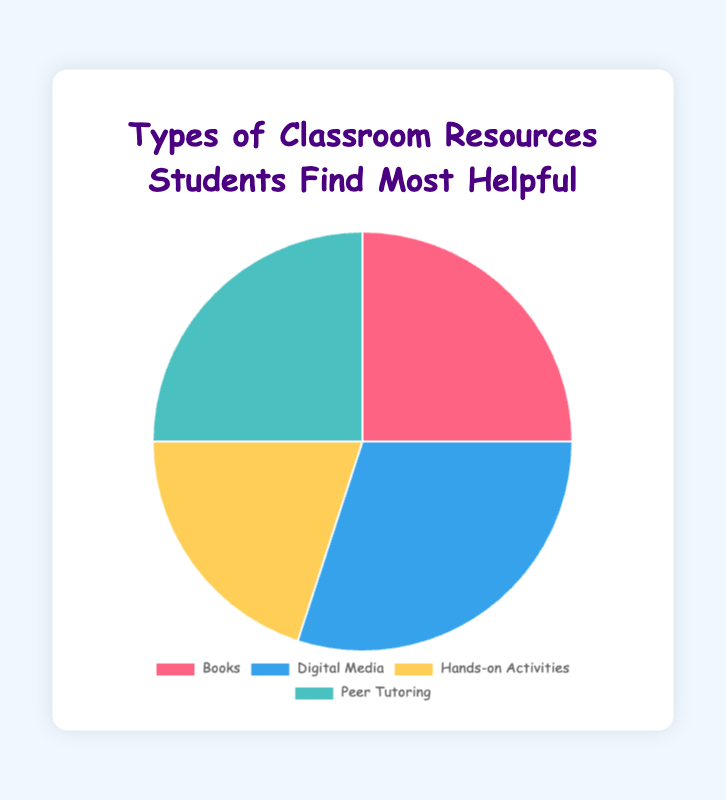Which resource type has the highest percentage? By examining the pie chart, we see that Digital Media occupies the largest portion of the chart. Its associated label shows 30%.
Answer: Digital Media How many percentage points higher is Digital Media compared to Hands-on Activities? Digital Media is 30% and Hands-on Activities is 20%. The difference is calculated as 30% - 20% = 10%.
Answer: 10% Which two resource types have the same percentage? By looking at the labels, we see that Books and Peer Tutoring each have a percentage of 25%.
Answer: Books and Peer Tutoring What percentage of students prefer Books or Peer Tutoring combined? Both Books and Peer Tutoring have a percentage of 25%, so the combined percentage is 25% + 25% = 50%.
Answer: 50% Which resource type occupies the smallest portion of the chart? Hands-on Activities is the smallest segment since its percentage is the lowest at 20%.
Answer: Hands-on Activities If you combine the percentages for Books and Hands-on Activities, are they greater than Digital Media? Books have 25% and Hands-on Activities have 20%, their combined percentage is 25% + 20% = 45%, which is greater than Digital Media's 30%.
Answer: Yes What is the average percentage of all resource types? Add all percentages: 25% + 30% + 20% + 25% = 100%. Divide by 4: 100% / 4 = 25%.
Answer: 25% Which colors represent Hands-on Activities and Peer Tutoring on the chart? Hands-on Activities is represented by a yellow section, and Peer Tutoring by a teal section.
Answer: yellow and teal By what percentage is Books less preferred than Digital Media? Books have a percentage of 25% and Digital Media have 30%. The difference is 30% - 25% = 5%.
Answer: 5% 